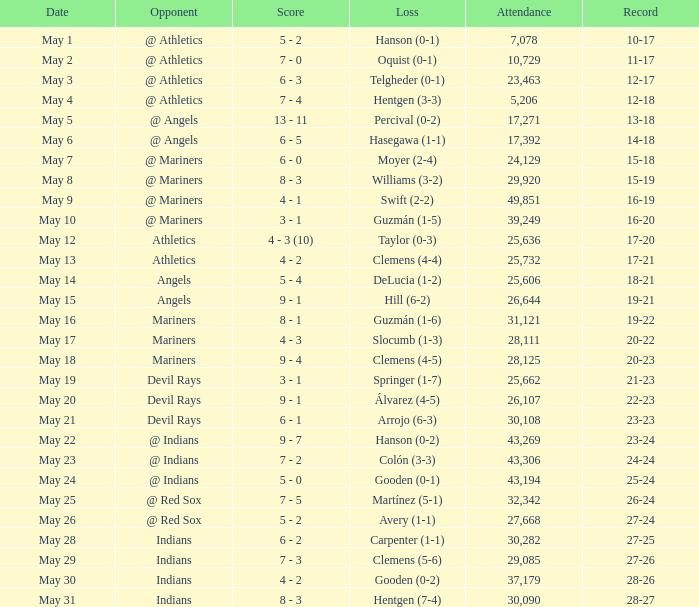Who lost on May 31? Hentgen (7-4). 